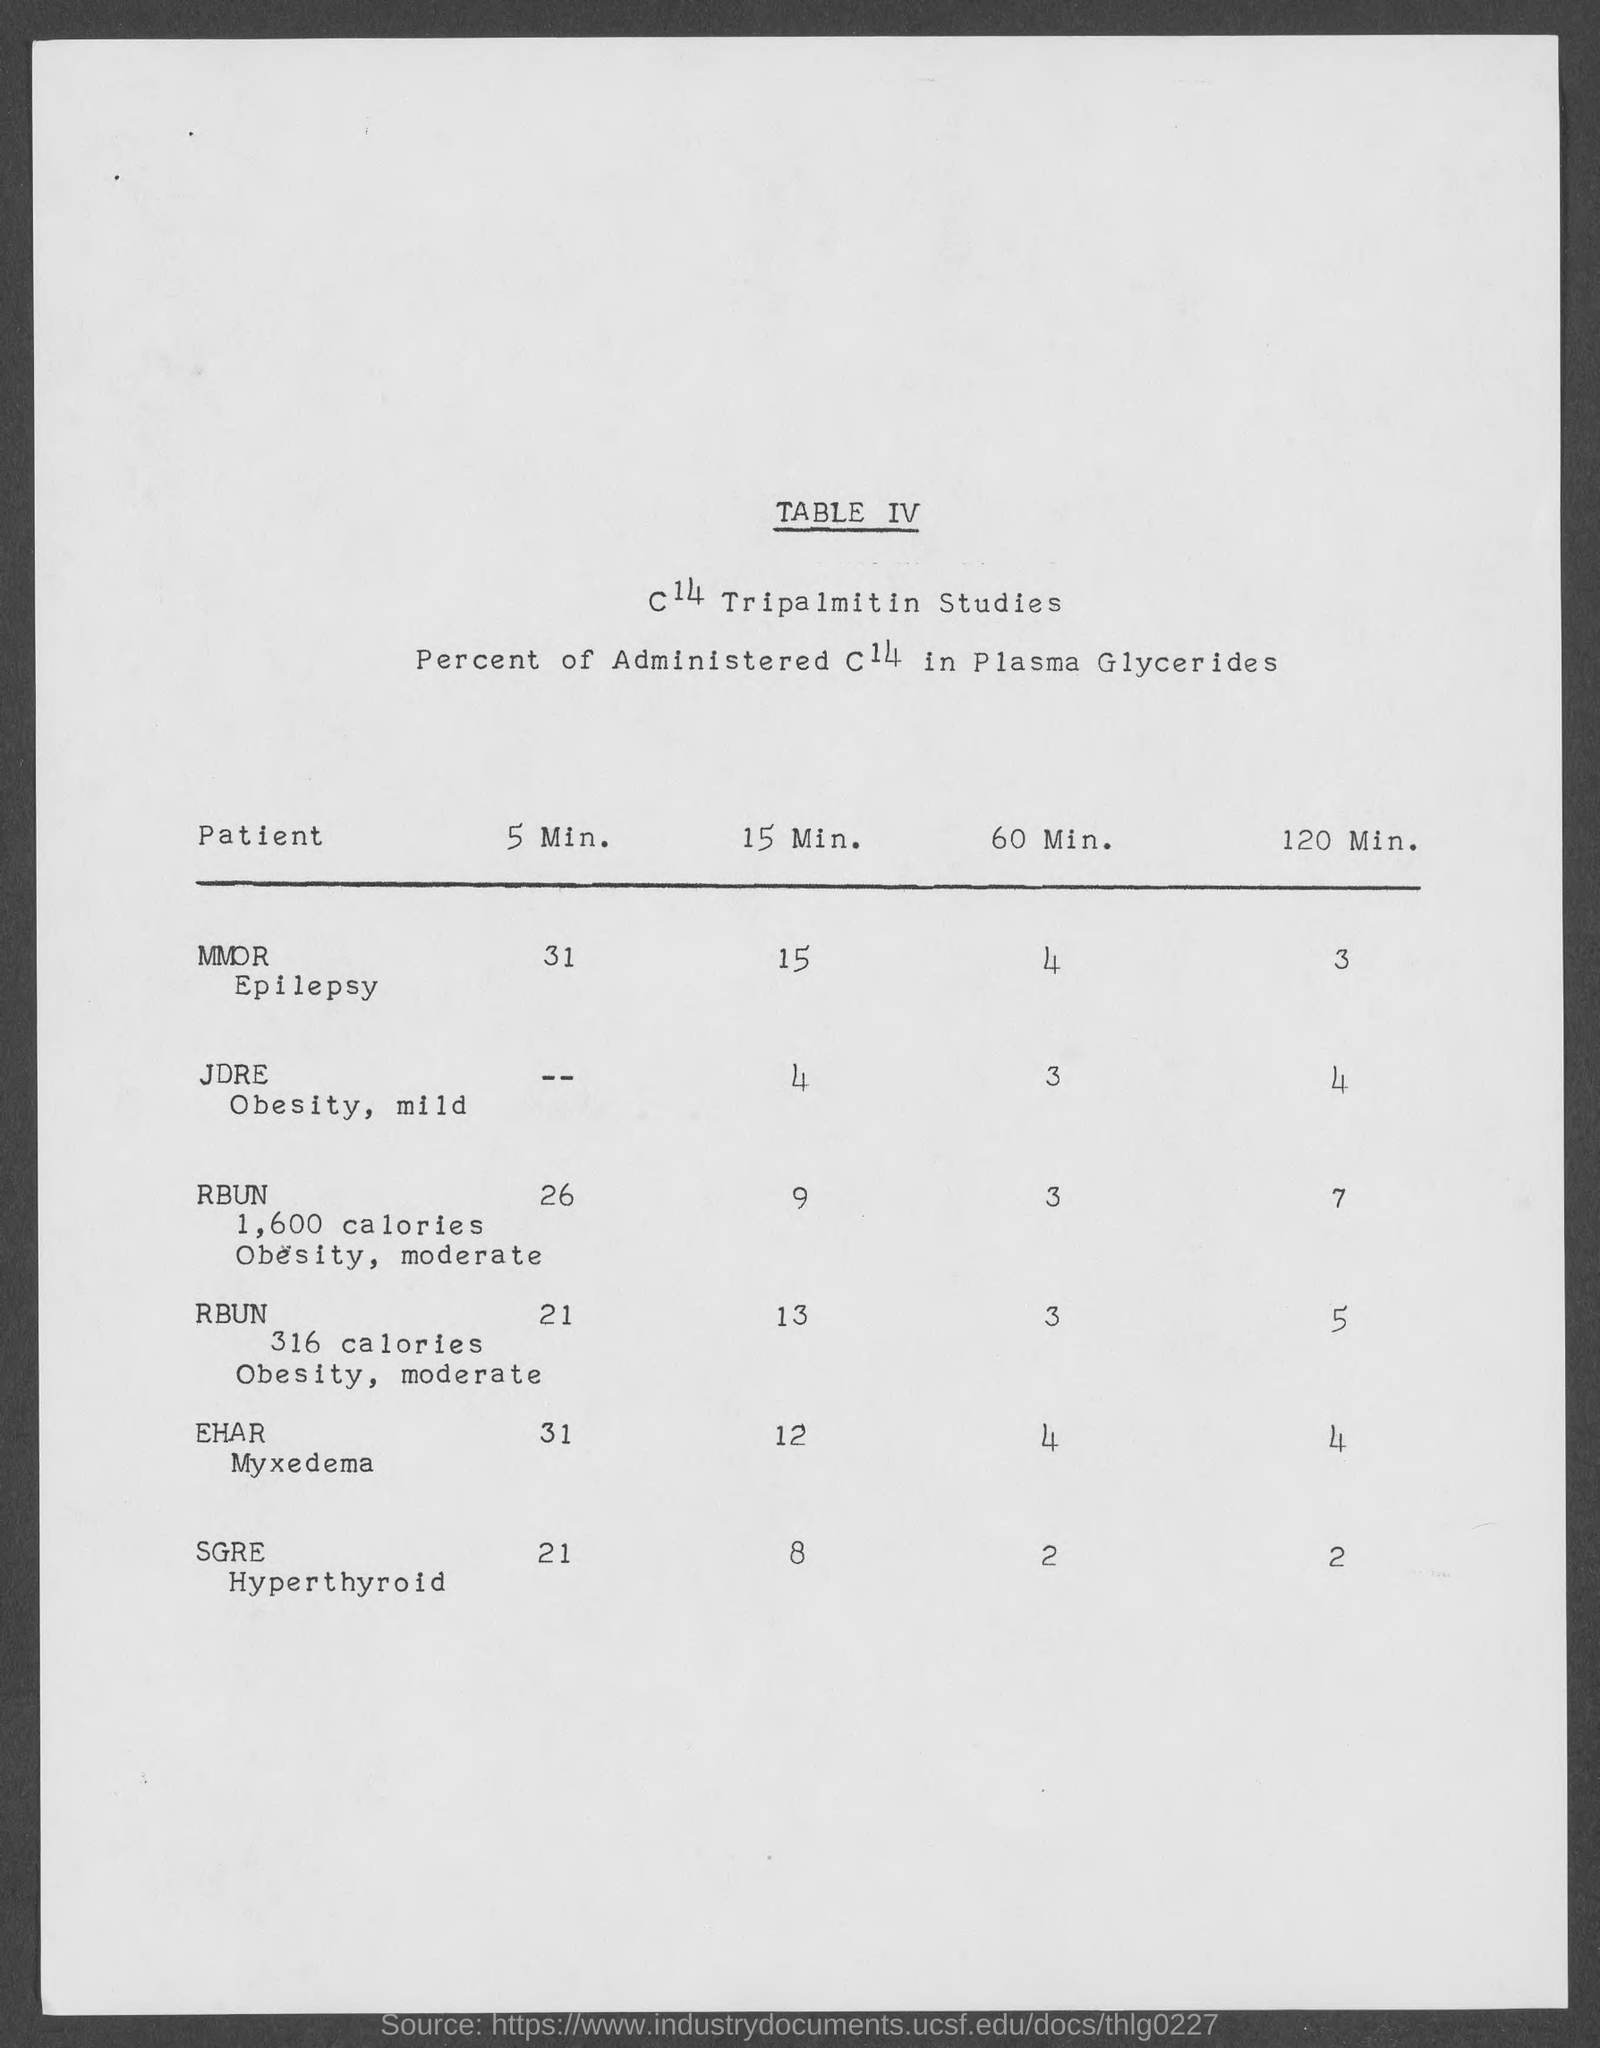What is the percent administered C14 in plasma glycerides in MMOR Epilepsy patient in 5 Min.?
Your answer should be compact. 31. What is the percent administered C14 in plasma glycerides in MMOR Epilepsy patient in 15 Min.?
Ensure brevity in your answer.  15. What is the percent administered C14 in plasma glycerides in MMOR Epilepsy patient in 60 Min.?
Provide a short and direct response. 4. What is the percent administered C14 in plasma glycerides in MMOR Epilepsy patient in 120 Min.?
Ensure brevity in your answer.  3. What is the percent administered C14 in plasma glycerides in JDRE Obesity, mild patient in 15 Min.?
Offer a terse response. 4. What is the percent administered C14 in plasma glycerides in JDRE Obesity, mild patient in 60 Min.?
Offer a terse response. 3. What is the percent administered C14 in plasma glycerides in JDRE Obesity, mild patient in 120 Min.?
Give a very brief answer. 4. What is the percent administered C14 in plasma glycerides in EHAR Myxedema patient in 15 Min.?
Offer a very short reply. 12. What is the percent administered C14 in plasma glycerides in EHAR Myxedema patient in 5 Min.?
Your answer should be very brief. 31. What is the percent administered C14 in plasma glycerides in EHAR Myxedema patient in 60 Min.?
Keep it short and to the point. 4. 